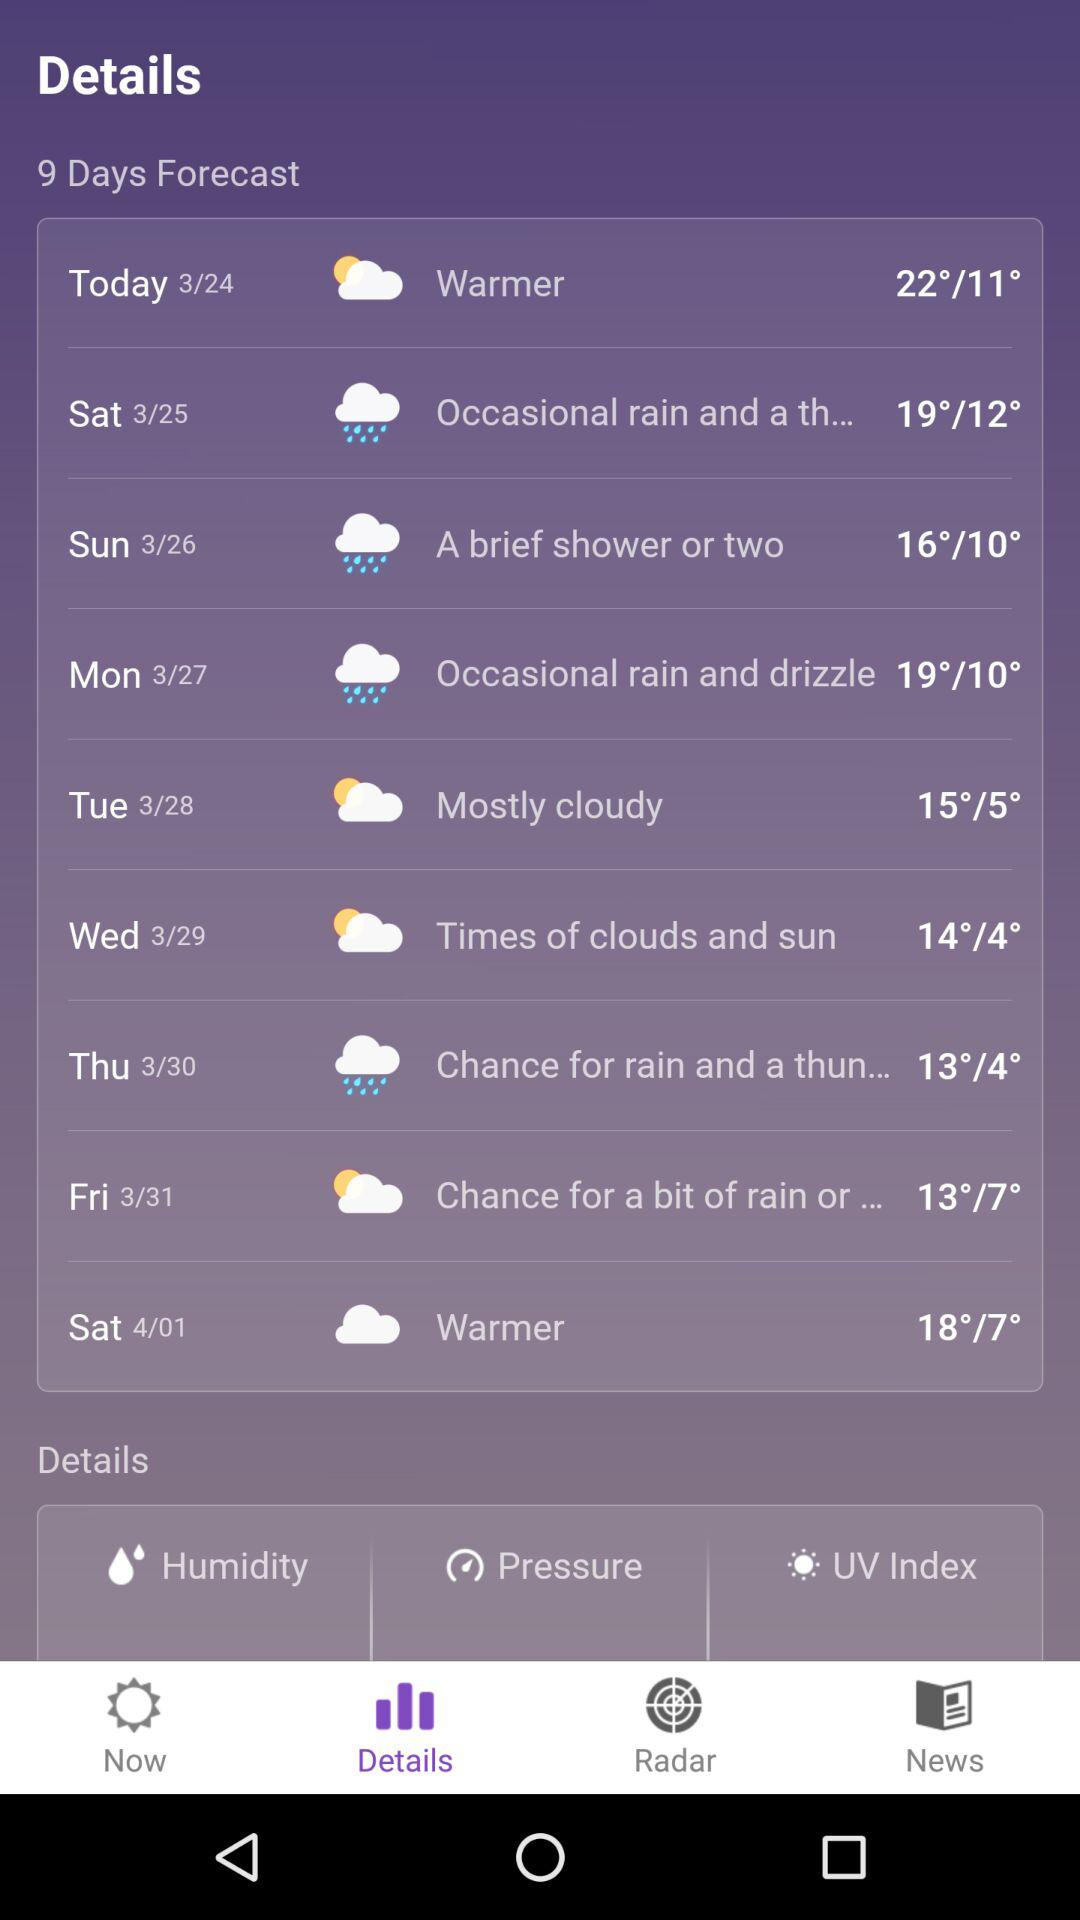How many days are forecast in this? There are 9 days forecast in this. 